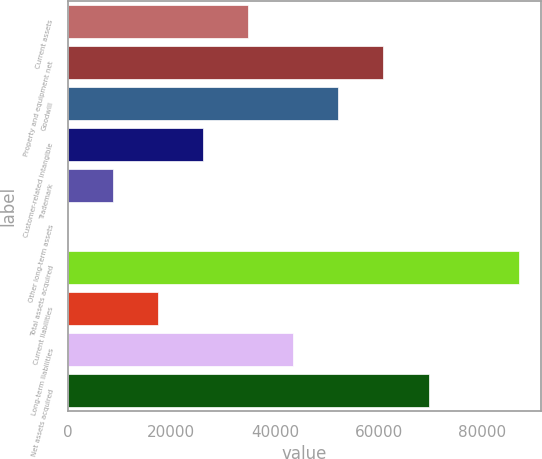Convert chart to OTSL. <chart><loc_0><loc_0><loc_500><loc_500><bar_chart><fcel>Current assets<fcel>Property and equipment net<fcel>Goodwill<fcel>Customer-related intangible<fcel>Trademark<fcel>Other long-term assets<fcel>Total assets acquired<fcel>Current liabilities<fcel>Long-term liabilities<fcel>Net assets acquired<nl><fcel>34818.2<fcel>60923.6<fcel>52221.8<fcel>26116.4<fcel>8712.8<fcel>11<fcel>87029<fcel>17414.6<fcel>43520<fcel>69625.4<nl></chart> 